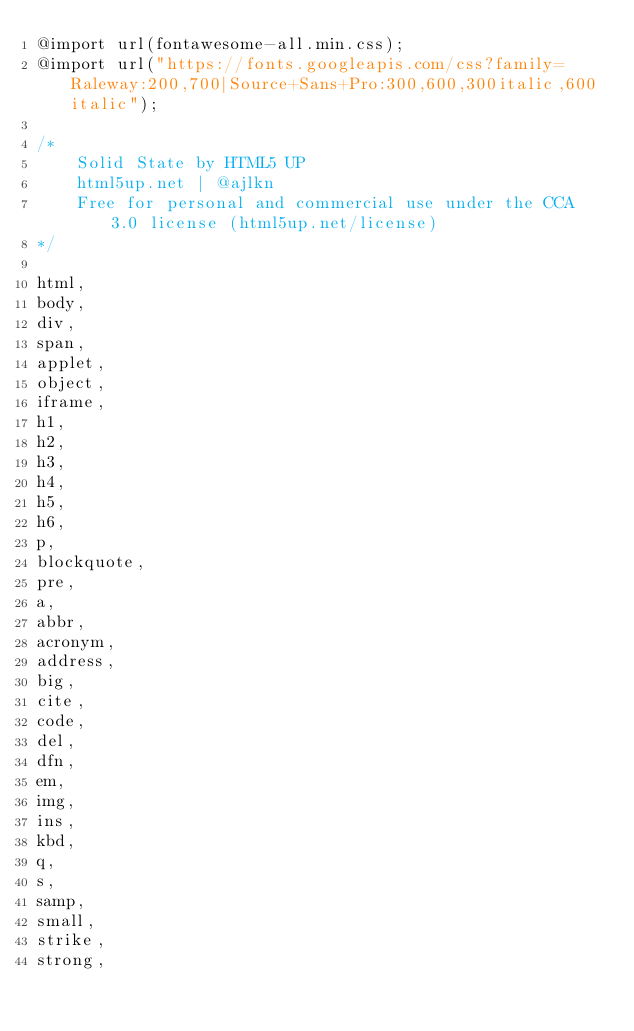<code> <loc_0><loc_0><loc_500><loc_500><_CSS_>@import url(fontawesome-all.min.css);
@import url("https://fonts.googleapis.com/css?family=Raleway:200,700|Source+Sans+Pro:300,600,300italic,600italic");

/*
	Solid State by HTML5 UP
	html5up.net | @ajlkn
	Free for personal and commercial use under the CCA 3.0 license (html5up.net/license)
*/

html,
body,
div,
span,
applet,
object,
iframe,
h1,
h2,
h3,
h4,
h5,
h6,
p,
blockquote,
pre,
a,
abbr,
acronym,
address,
big,
cite,
code,
del,
dfn,
em,
img,
ins,
kbd,
q,
s,
samp,
small,
strike,
strong,</code> 